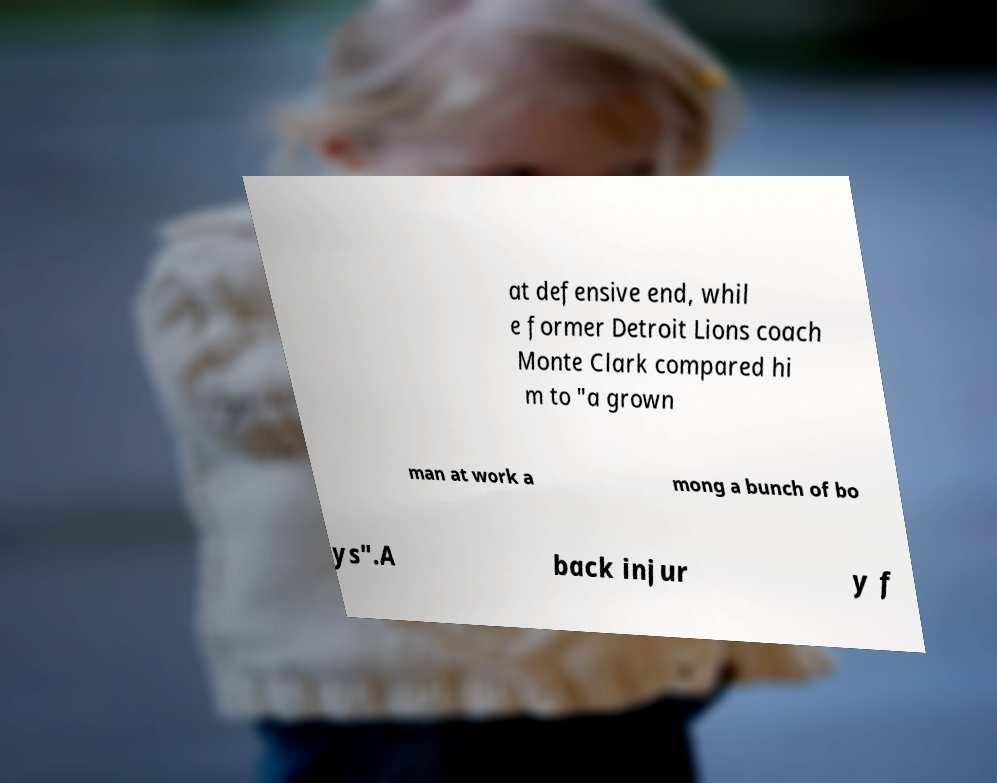Could you assist in decoding the text presented in this image and type it out clearly? at defensive end, whil e former Detroit Lions coach Monte Clark compared hi m to "a grown man at work a mong a bunch of bo ys".A back injur y f 